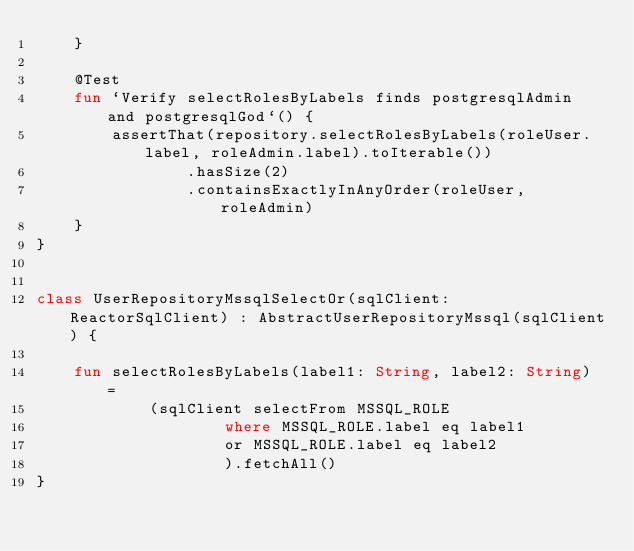<code> <loc_0><loc_0><loc_500><loc_500><_Kotlin_>    }

    @Test
    fun `Verify selectRolesByLabels finds postgresqlAdmin and postgresqlGod`() {
        assertThat(repository.selectRolesByLabels(roleUser.label, roleAdmin.label).toIterable())
                .hasSize(2)
                .containsExactlyInAnyOrder(roleUser, roleAdmin)
    }
}


class UserRepositoryMssqlSelectOr(sqlClient: ReactorSqlClient) : AbstractUserRepositoryMssql(sqlClient) {

    fun selectRolesByLabels(label1: String, label2: String) =
            (sqlClient selectFrom MSSQL_ROLE
                    where MSSQL_ROLE.label eq label1
                    or MSSQL_ROLE.label eq label2
                    ).fetchAll()
}
</code> 